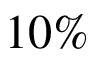<formula> <loc_0><loc_0><loc_500><loc_500>1 0 \%</formula> 